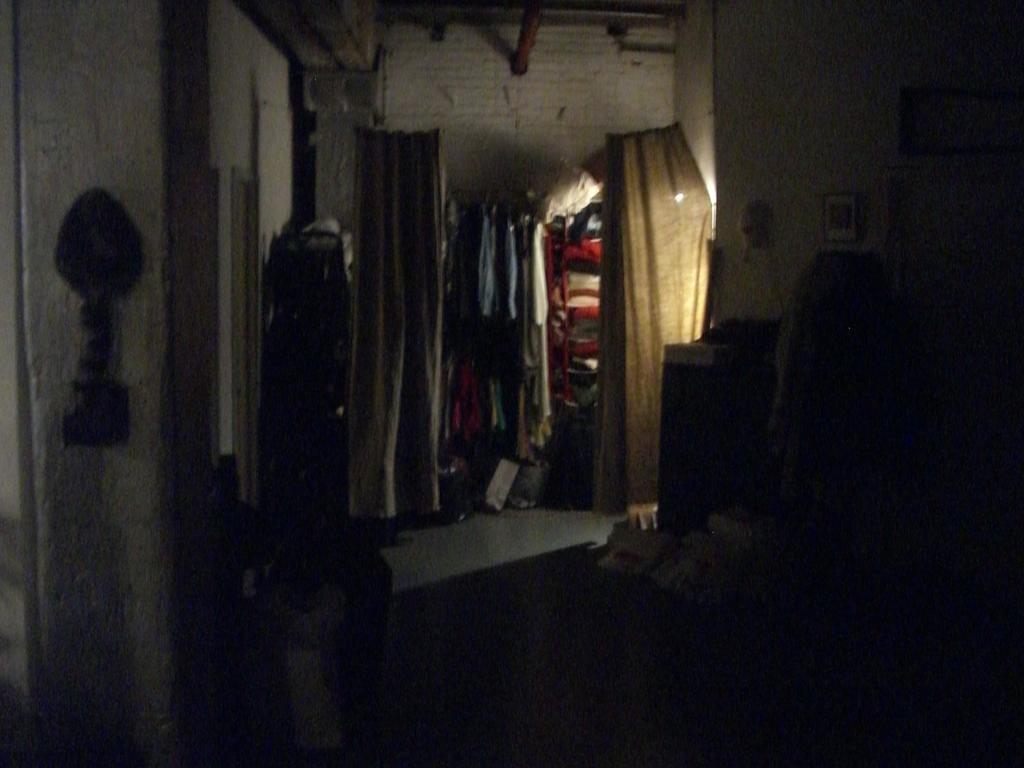Describe this image in one or two sentences. This image is taken indoors. This image is a little dark. In the background there are a few walls. There are a few clothes and there are a few objects. 